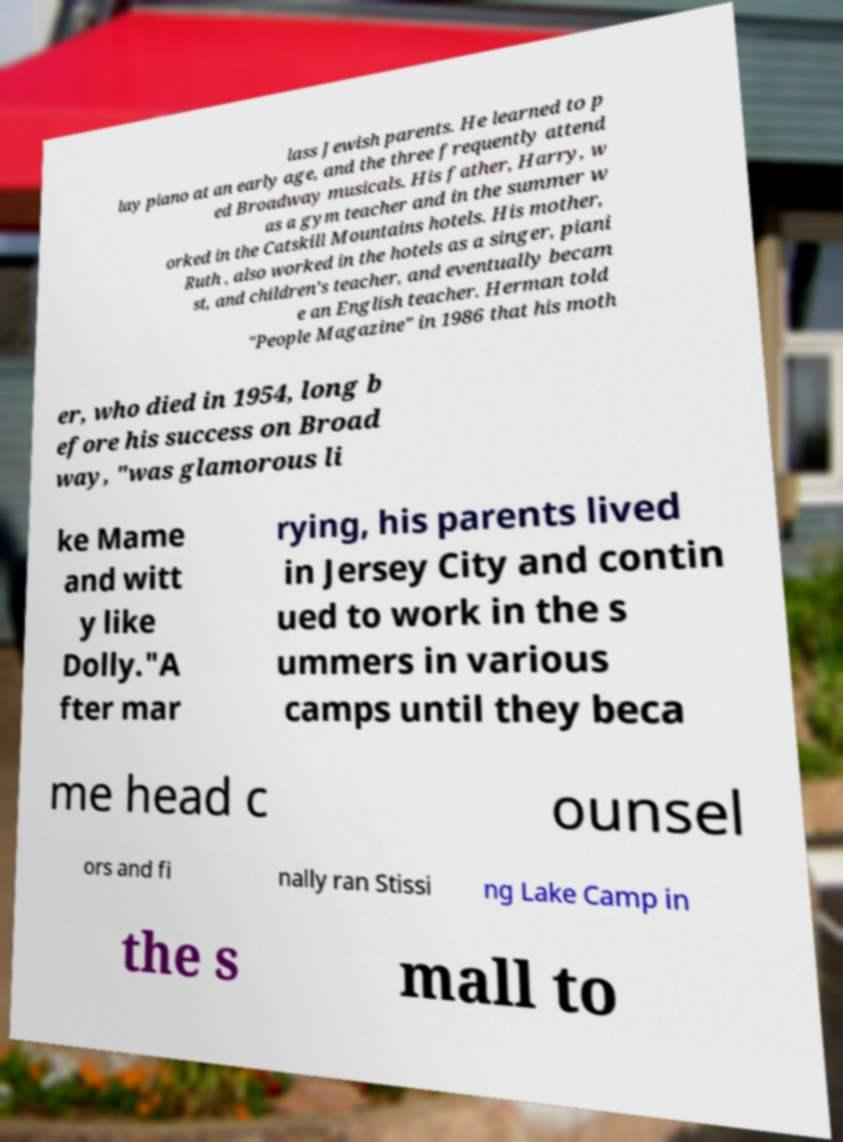For documentation purposes, I need the text within this image transcribed. Could you provide that? lass Jewish parents. He learned to p lay piano at an early age, and the three frequently attend ed Broadway musicals. His father, Harry, w as a gym teacher and in the summer w orked in the Catskill Mountains hotels. His mother, Ruth , also worked in the hotels as a singer, piani st, and children's teacher, and eventually becam e an English teacher. Herman told "People Magazine" in 1986 that his moth er, who died in 1954, long b efore his success on Broad way, "was glamorous li ke Mame and witt y like Dolly."A fter mar rying, his parents lived in Jersey City and contin ued to work in the s ummers in various camps until they beca me head c ounsel ors and fi nally ran Stissi ng Lake Camp in the s mall to 